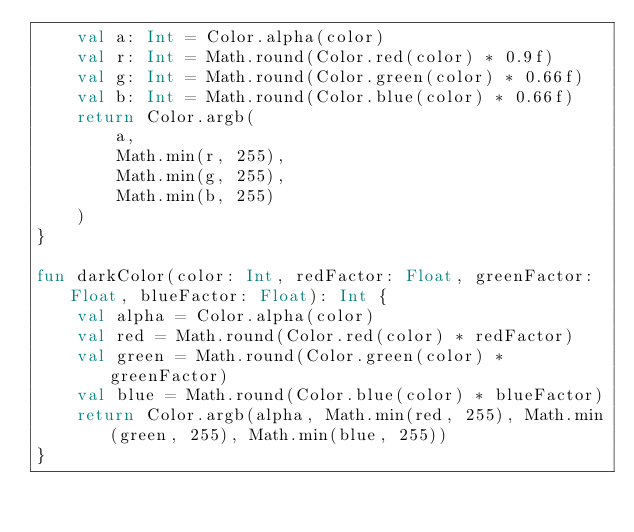<code> <loc_0><loc_0><loc_500><loc_500><_Kotlin_>    val a: Int = Color.alpha(color)
    val r: Int = Math.round(Color.red(color) * 0.9f)
    val g: Int = Math.round(Color.green(color) * 0.66f)
    val b: Int = Math.round(Color.blue(color) * 0.66f)
    return Color.argb(
        a,
        Math.min(r, 255),
        Math.min(g, 255),
        Math.min(b, 255)
    )
}

fun darkColor(color: Int, redFactor: Float, greenFactor: Float, blueFactor: Float): Int {
    val alpha = Color.alpha(color)
    val red = Math.round(Color.red(color) * redFactor)
    val green = Math.round(Color.green(color) * greenFactor)
    val blue = Math.round(Color.blue(color) * blueFactor)
    return Color.argb(alpha, Math.min(red, 255), Math.min(green, 255), Math.min(blue, 255))
}</code> 